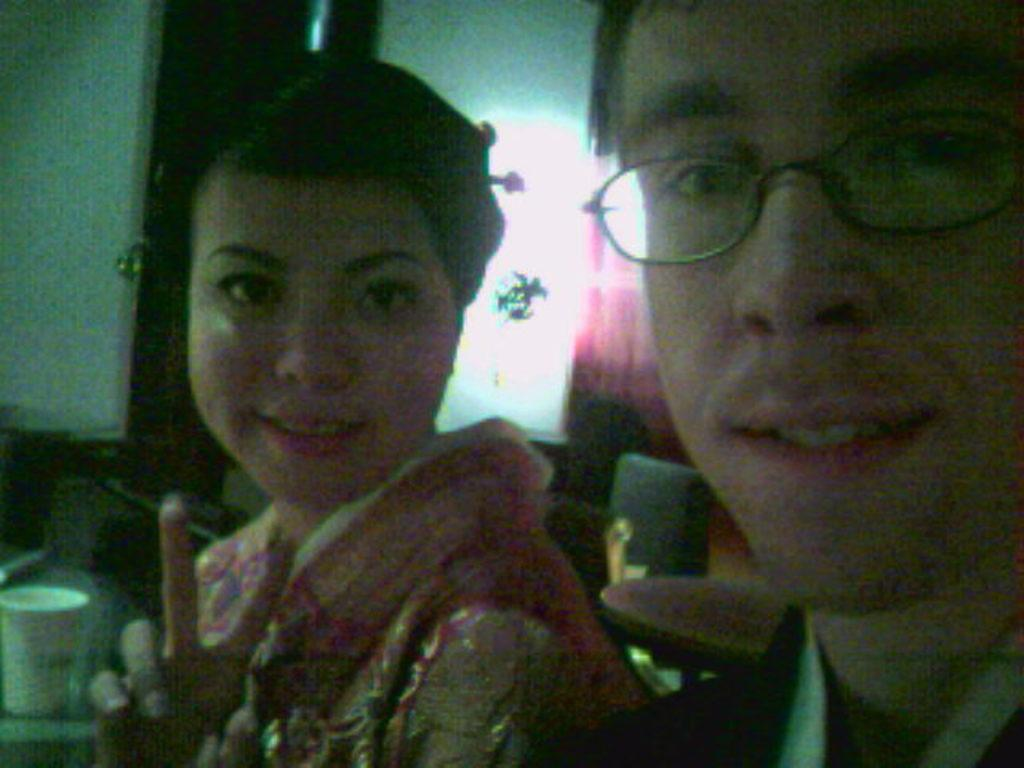How many people are present in the image? There is a man and a woman in the image. What objects can be seen in the image? There is a table, a chair, and a cup in the image. What is the purpose of the chair in the image? The chair is likely for sitting, as it is commonly used for that purpose. What can be seen in the background of the image? There are objects in the background of the image. What type of key is being used to unlock the hand in the image? There is no key or hand present in the image. How is the wire being used in the image? There is no wire present in the image. 